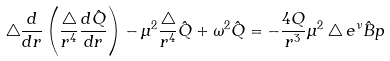<formula> <loc_0><loc_0><loc_500><loc_500>\bigtriangleup \frac { d } { d r } \left ( \frac { \bigtriangleup } { r ^ { 4 } } \frac { d \hat { Q } } { d r } \right ) - \mu ^ { 2 } \frac { \bigtriangleup } { r ^ { 4 } } \hat { Q } + \omega ^ { 2 } \hat { Q } = - \frac { 4 Q } { r ^ { 3 } } \mu ^ { 2 } \bigtriangleup e ^ { \nu } \hat { B } p</formula> 